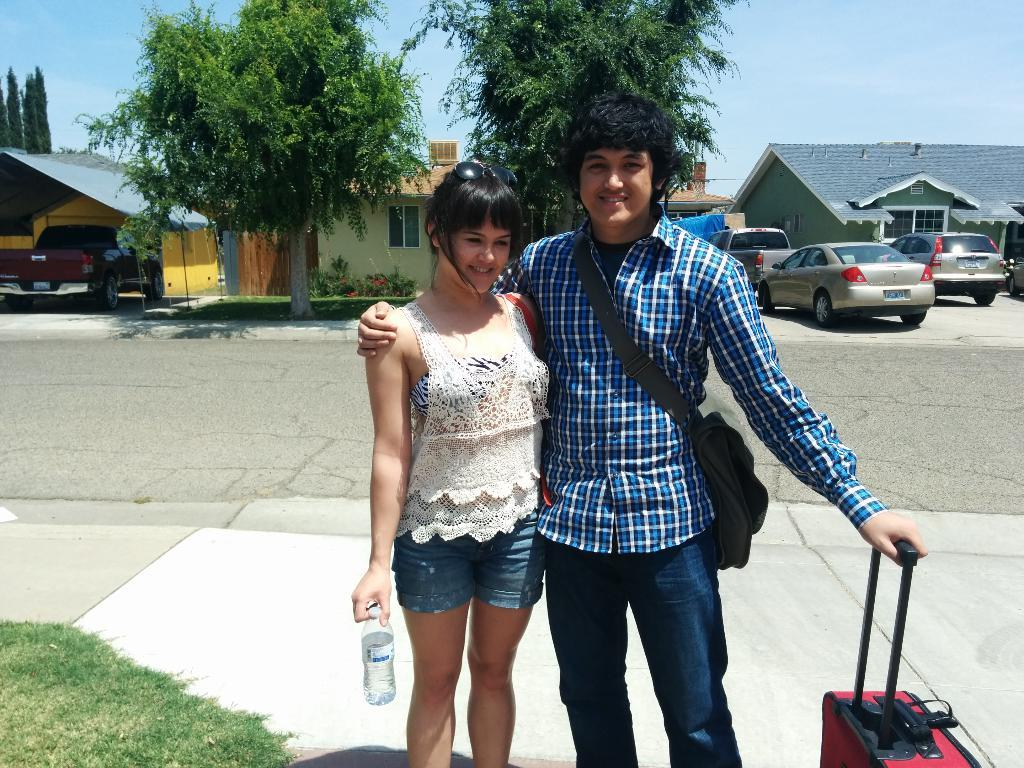How many people are present in the image? There are two people, a man and a woman, present in the image. What are the man and the woman doing in the image? Both the man and the woman are standing on the ground. What are the man and the woman holding in their hands? The man and the woman are holding objects in their hands, but the specific objects are not mentioned in the facts. What can be seen in the background of the image? There is grass, houses, trees, vehicles, and the sky visible in the background of the image. What type of toothpaste is the man using to blow bubbles in the image? There is no toothpaste or bubbles present in the image. How does the woman shake the tree in the image? There is no tree-shaking activity depicted in the image. 